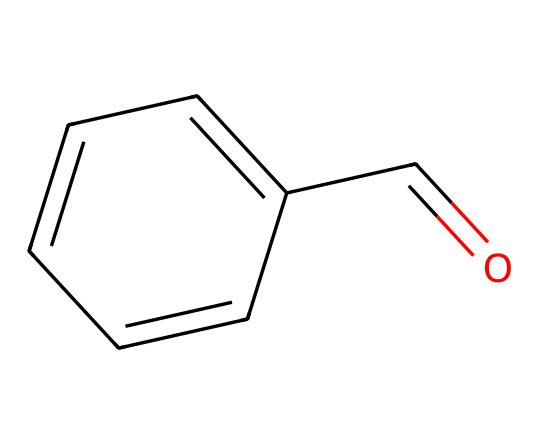What is the molecular formula of this compound? By analyzing the SMILES representation, we can count the number of carbon (C), hydrogen (H), and oxygen (O) atoms present. The structure indicates 8 carbon atoms, 8 hydrogen atoms, and 1 oxygen atom. Therefore, the molecular formula is C8H8O.
Answer: C8H8O How many rings are present in this structure? In the SMILES notation, there are no numbers indicating the presence of rings. Additionally, upon visualizing the structure, it consists of a linear chain of atoms without any ring structures. Therefore, there are zero rings.
Answer: 0 What type of functional group is present in benzaldehyde? Looking at the chemical structure, we identify the –CHO group, where the carbon is double-bonded to oxygen and single-bonded to hydrogen. This characteristic functional group is known as an aldehyde.
Answer: aldehyde How many double bonds are present in this molecule? By closely examining the structure, we can see that there is one double bond in the carbon-oxygen connection of the –CHO group, which qualifies as a double bond. Therefore, there is one double bond in total.
Answer: 1 What is the primary flavor profile associated with benzaldehyde? Benzaldehyde is known primarily for its almond flavor profile, which is indicative of its aromatic nature and presence in various food products as a flavoring agent.
Answer: almond How does the molecular structure of benzaldehyde contribute to its solubility in organic solvents? The presence of the aromatic ring provides stability and hydrophobic character, while the polar –CHO group can engage in dipole-dipole interactions with organic solvents. Thus, its structure allows good solubility in non-polar organic solvents.
Answer: good solubility What is the significance of benzaldehyde in the fragrance industry? Benzaldehyde’s pleasant almond scent makes it a popular choice as a fragrance ingredient in perfumes and cosmetics, often adding a sweet, nutty scent profile that enhances various products.
Answer: fragrance ingredient 